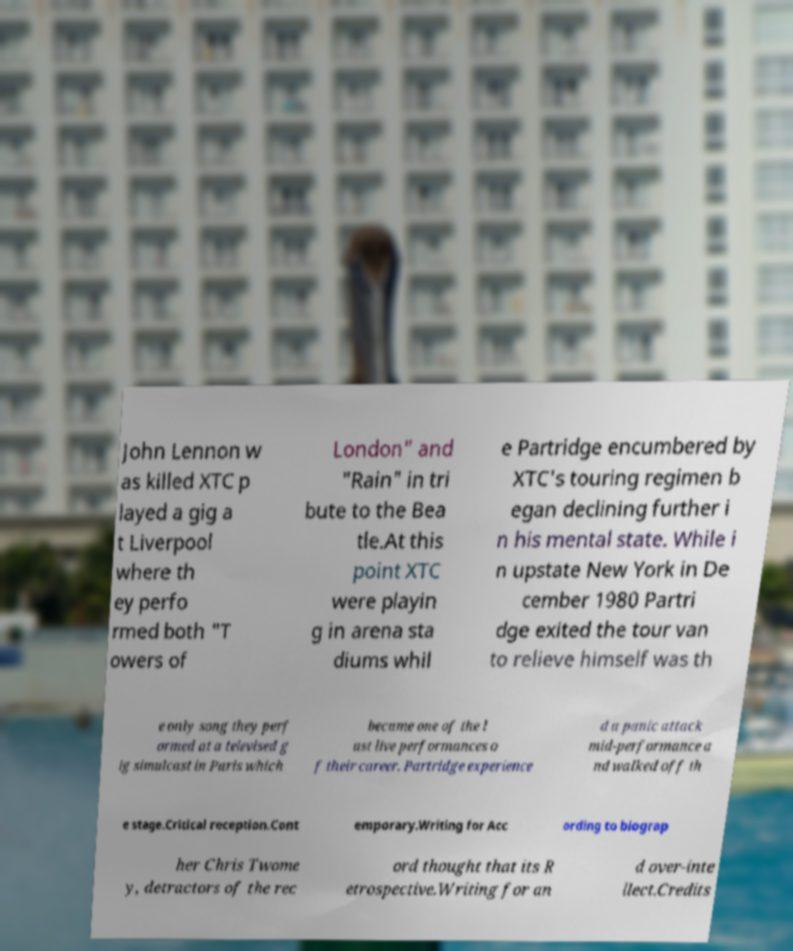For documentation purposes, I need the text within this image transcribed. Could you provide that? John Lennon w as killed XTC p layed a gig a t Liverpool where th ey perfo rmed both "T owers of London" and "Rain" in tri bute to the Bea tle.At this point XTC were playin g in arena sta diums whil e Partridge encumbered by XTC's touring regimen b egan declining further i n his mental state. While i n upstate New York in De cember 1980 Partri dge exited the tour van to relieve himself was th e only song they perf ormed at a televised g ig simulcast in Paris which became one of the l ast live performances o f their career. Partridge experience d a panic attack mid-performance a nd walked off th e stage.Critical reception.Cont emporary.Writing for Acc ording to biograp her Chris Twome y, detractors of the rec ord thought that its R etrospective.Writing for an d over-inte llect.Credits 